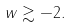<formula> <loc_0><loc_0><loc_500><loc_500>w \gtrsim - 2 .</formula> 